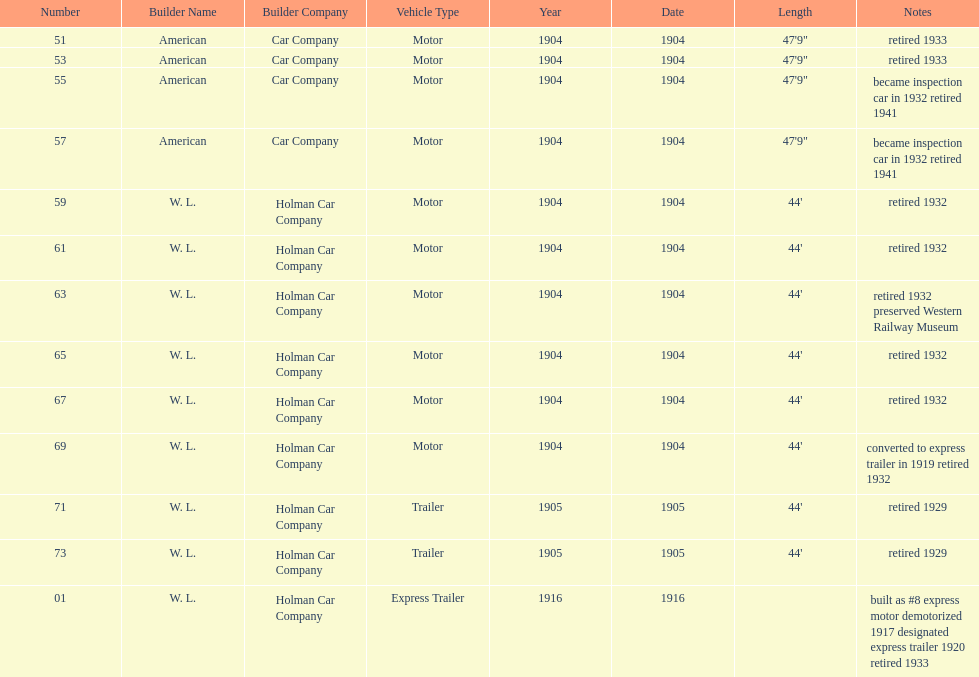What was the total number of cars listed? 13. Would you be able to parse every entry in this table? {'header': ['Number', 'Builder Name', 'Builder Company', 'Vehicle Type', 'Year', 'Date', 'Length', 'Notes'], 'rows': [['51', 'American', 'Car Company', 'Motor', '1904', '1904', '47\'9"', 'retired 1933'], ['53', 'American', 'Car Company', 'Motor', '1904', '1904', '47\'9"', 'retired 1933'], ['55', 'American', 'Car Company', 'Motor', '1904', '1904', '47\'9"', 'became inspection car in 1932 retired 1941'], ['57', 'American', 'Car Company', 'Motor', '1904', '1904', '47\'9"', 'became inspection car in 1932 retired 1941'], ['59', 'W. L.', 'Holman Car Company', 'Motor', '1904', '1904', "44'", 'retired 1932'], ['61', 'W. L.', 'Holman Car Company', 'Motor', '1904', '1904', "44'", 'retired 1932'], ['63', 'W. L.', 'Holman Car Company', 'Motor', '1904', '1904', "44'", 'retired 1932 preserved Western Railway Museum'], ['65', 'W. L.', 'Holman Car Company', 'Motor', '1904', '1904', "44'", 'retired 1932'], ['67', 'W. L.', 'Holman Car Company', 'Motor', '1904', '1904', "44'", 'retired 1932'], ['69', 'W. L.', 'Holman Car Company', 'Motor', '1904', '1904', "44'", 'converted to express trailer in 1919 retired 1932'], ['71', 'W. L.', 'Holman Car Company', 'Trailer', '1905', '1905', "44'", 'retired 1929'], ['73', 'W. L.', 'Holman Car Company', 'Trailer', '1905', '1905', "44'", 'retired 1929'], ['01', 'W. L.', 'Holman Car Company', 'Express Trailer', '1916', '1916', '', 'built as #8 express motor demotorized 1917 designated express trailer 1920 retired 1933']]} 